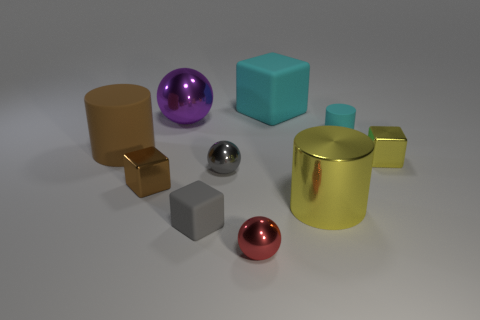Subtract all cubes. How many objects are left? 6 Subtract 0 green cubes. How many objects are left? 10 Subtract all large yellow matte things. Subtract all brown rubber cylinders. How many objects are left? 9 Add 1 yellow cylinders. How many yellow cylinders are left? 2 Add 10 large brown matte cubes. How many large brown matte cubes exist? 10 